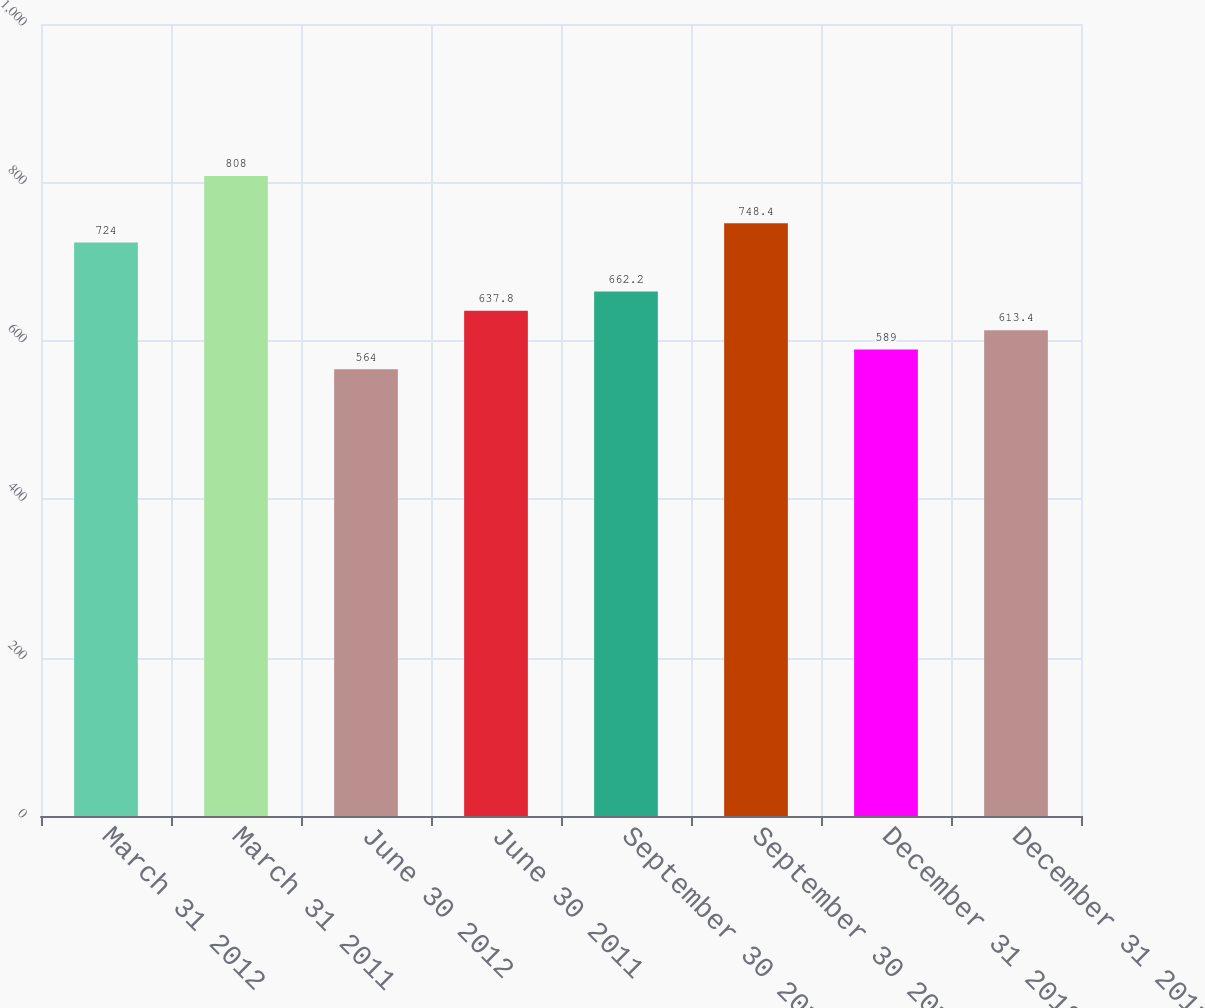Convert chart to OTSL. <chart><loc_0><loc_0><loc_500><loc_500><bar_chart><fcel>March 31 2012<fcel>March 31 2011<fcel>June 30 2012<fcel>June 30 2011<fcel>September 30 2012<fcel>September 30 2011<fcel>December 31 2012<fcel>December 31 2011<nl><fcel>724<fcel>808<fcel>564<fcel>637.8<fcel>662.2<fcel>748.4<fcel>589<fcel>613.4<nl></chart> 